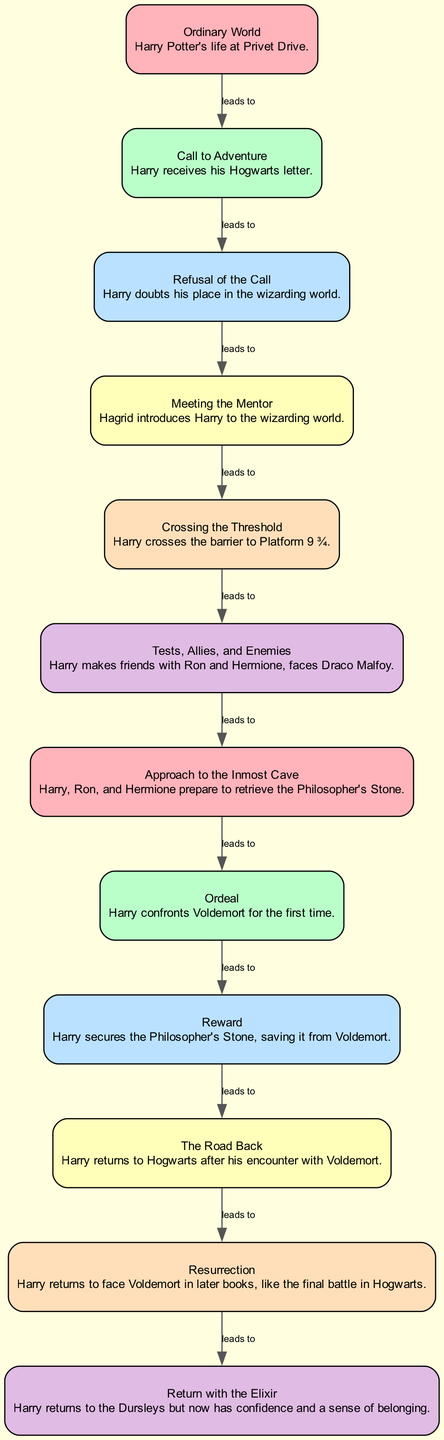What is the first node in the hero's journey? The first node in the diagram is labeled "Ordinary World," which represents the hero's normal life before the adventure begins.
Answer: Ordinary World How many nodes are there in the hero's journey? By counting the nodes listed in the data, there are a total of 12 nodes that represent different stages in the hero's journey.
Answer: 12 What leads to the "Ordeal"? The "Approach to the Inmost Cave" node leads to the "Ordeal" in the sequence, indicating that the hero encounters challenges as they prepare for their greatest test.
Answer: Approach to the Inmost Cave Which node follows "Reward"? According to the flow of the diagram, the "Road Back" node directly follows the "Reward" node, illustrating the hero's journey home after achieving their goal.
Answer: The Road Back What is the example provided for "Meeting the Mentor"? The example given for the "Meeting the Mentor" node is "Hagrid introduces Harry to the wizarding world," demonstrating how a mentor assists the hero.
Answer: Hagrid introduces Harry to the wizarding world What is the relationship between the "Call to Adventure" and "Refusal of the Call"? The "Call to Adventure" leads to the "Refusal of the Call," indicating a direct sequence where the hero is first called to action but then hesitates.
Answer: leads to What key transformation does the hero undergo by the end of the journey? By the end of the journey, in the "Return with the Elixir" stage, the hero is transformed with newfound confidence and a sense of belonging.
Answer: Confidence and belonging Which example illustrates the "Ordeal"? The "Ordeal" node is exemplified by "Harry confronts Voldemort for the first time," showing the climactic challenge the hero faces.
Answer: Harry confronts Voldemort for the first time What connects "Tests, Allies, and Enemies" to "Approach to the Inmost Cave"? The direct connection is that "Tests, Allies, and Enemies" leads to "Approach to the Inmost Cave," showing that after facing challenges, the hero prepares for a deeper confrontation.
Answer: leads to 